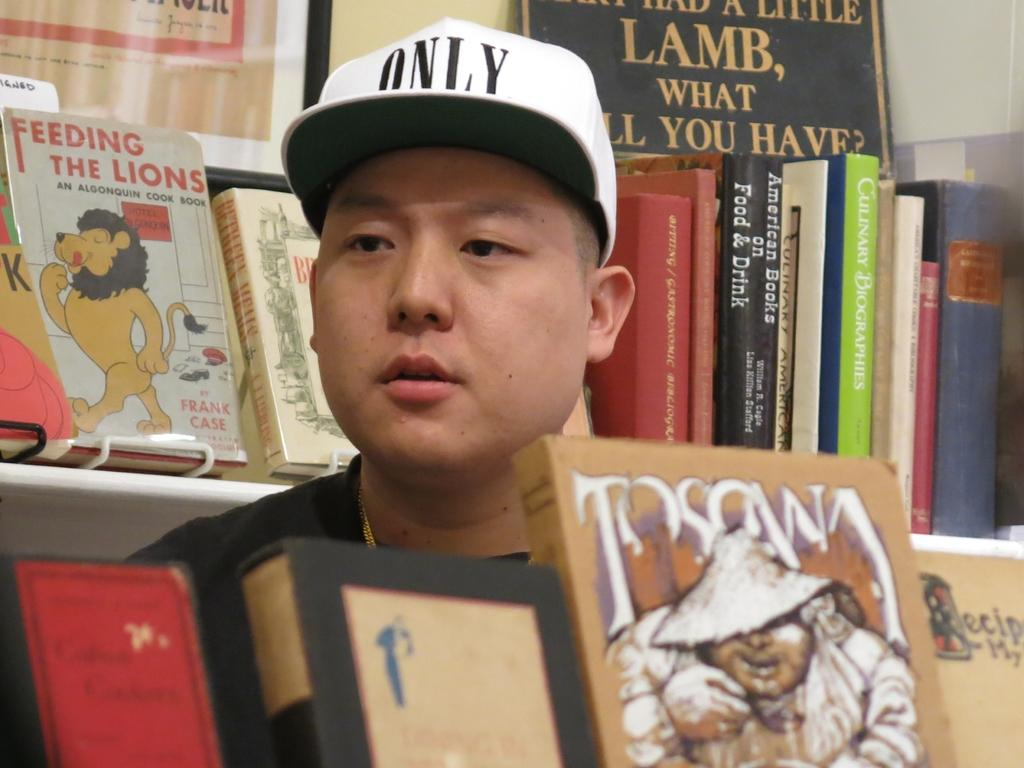<image>
Provide a brief description of the given image. An Asian man in an isle of books with one behind him titled Feeding the Lions. 